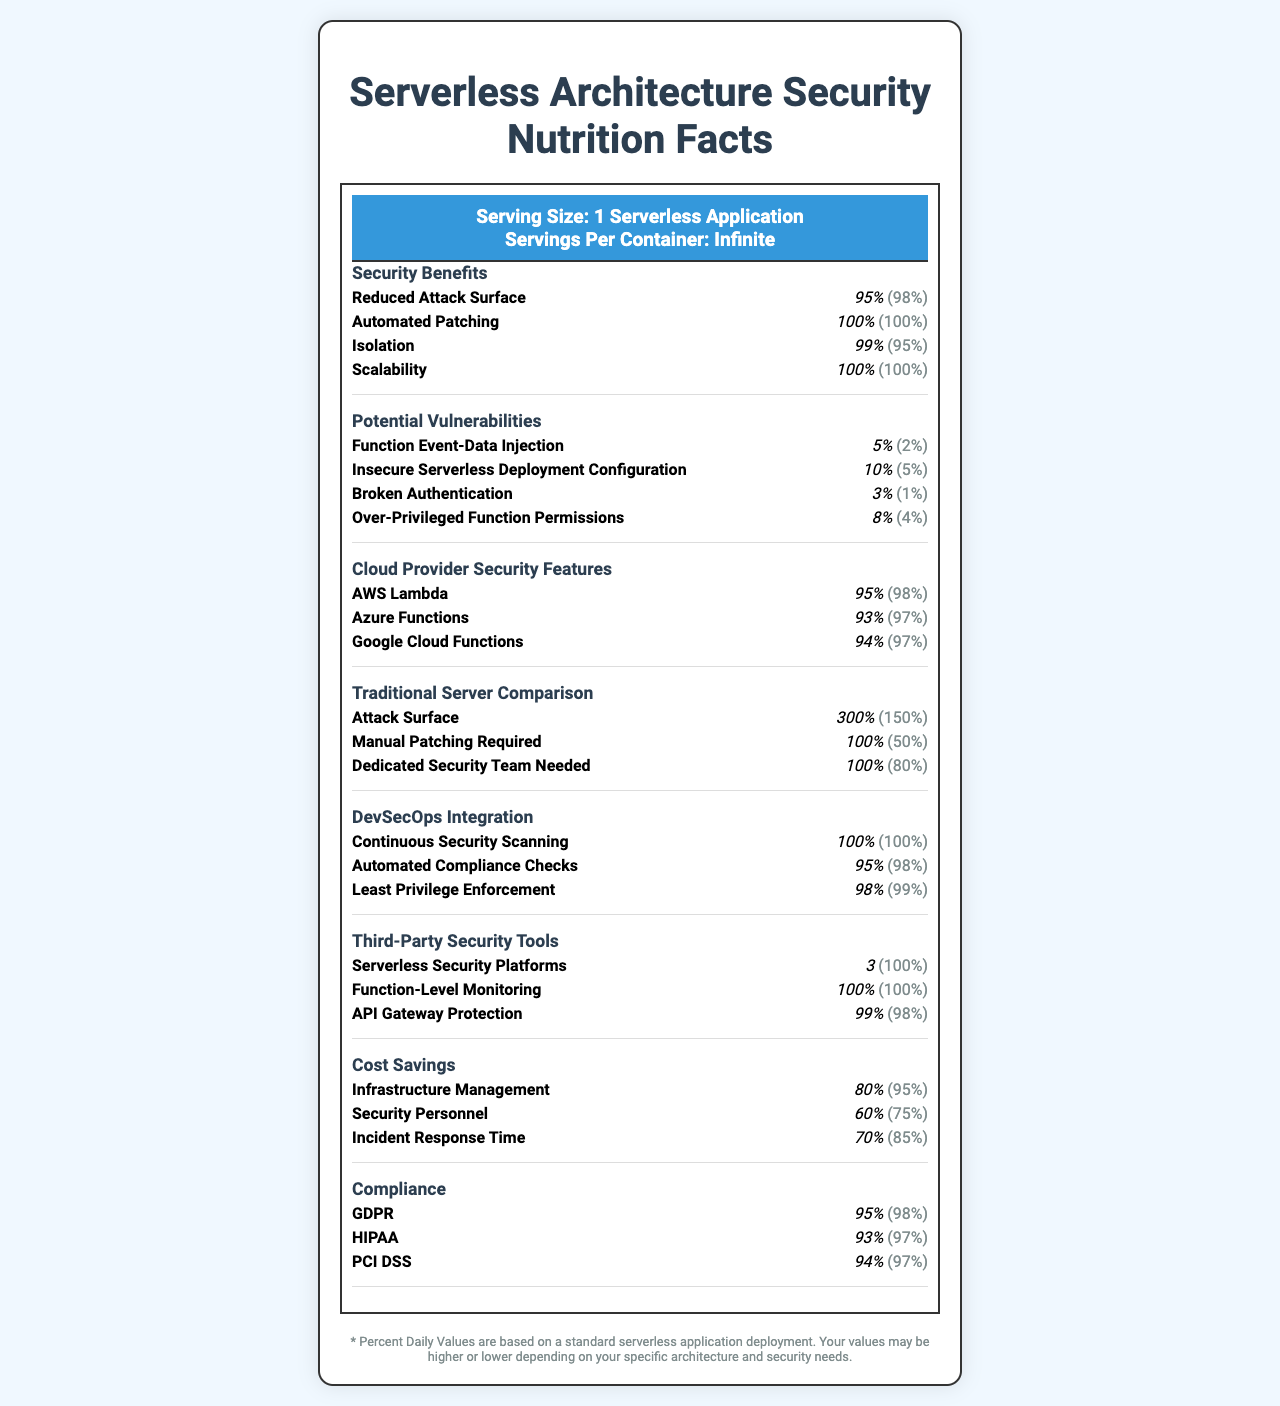what is the Serving Size of this document? The Serving Size listed at the top of the document is "1 Serverless Application".
Answer: 1 Serverless Application how much is the Automated Patching in terms of amount and daily value percentage? In the "Security Benefits" section, Automated Patching is listed with an amount of 100% and a daily value of 100%.
Answer: amount: 100%, daily value: 100% what is the daily value percentage for Reduced Attack Surface in serverless architecture? The daily value for Reduced Attack Surface in the "Security Benefits" section is listed as 98%.
Answer: 98% what is the amount of Insecure Serverless Deployment Configuration vulnerability? The amount of Insecure Serverless Deployment Configuration under "Potential Vulnerabilities" is 10%.
Answer: 10% which cloud provider has the highest amount percentage for security features? A. AWS Lambda B. Azure Functions C. Google Cloud Functions AWS Lambda has a 95% amount, which is higher than Azure Functions (93%) and Google Cloud Functions (94%).
Answer: A. AWS Lambda which of the following is a security vulnerability specific to serverless architecture? A. Function Event-Data Injection B. Manual Patching Required C. Dedicated Security Team Needed Function Event-Data Injection is listed under "Potential Vulnerabilities" whereas Manual Patching Required and Dedicated Security Team Needed are under "Traditional Server Comparison".
Answer: A. Function Event-Data Injection does the document indicate that serverless architecture has automated patching? Automated Patching is listed under "Security Benefits" with an amount of 100% and daily value of 100%.
Answer: Yes what does the document say about the cost savings in terms of infrastructure management? Under "Cost Savings", the Infrastructure Management benefits show an amount of 80% and a daily value of 95%.
Answer: amount: 80%, daily value: 95% summarize the main idea of the document. The document is a visual comparison presented as a Nutrition Facts Label, illustrating the benefits and potential vulnerabilities of serverless architecture in terms of security aspects and comparing them with traditional servers.
Answer: The document compares the security benefits and vulnerabilities of serverless architecture versus traditional server setups. It highlights serverless advantages like reduced attack surfaces, automated patching, and cost savings, while also noting potential vulnerabilities and security features from major cloud providers. is AWS Lambda reviewed better in security features than Google Cloud Functions? AWS Lambda has a higher amount percentage (95%) compared to Google Cloud Functions (94%).
Answer: Yes how much more is the attack surface in traditional server setups compared to serverless architecture? The Traditional Server Comparison section states that the Attack Surface is 300%, whereas the serverless architecture (under Security Benefits) lists a Reduced Attack Surface amount of 95%.
Answer: 300% vs. 95% how often is manual patching required in serverless architecture? The document does not specify how often manual patching is required for serverless architecture, but it implies automated patching is utilized.
Answer: Cannot be determined what is the potential vulnerability related to broken authentication's daily value? Under "Potential Vulnerabilities", Broken Authentication has a daily value of 1%.
Answer: 1% how does the document depict the need for a dedicated security team in traditional server setups? The "Traditional Server Comparison" section lists the need for a Dedicated Security Team with an amount of 100% and a daily value of 80%.
Answer: The document depicts it with an amount of 100% and a daily value of 80%. 